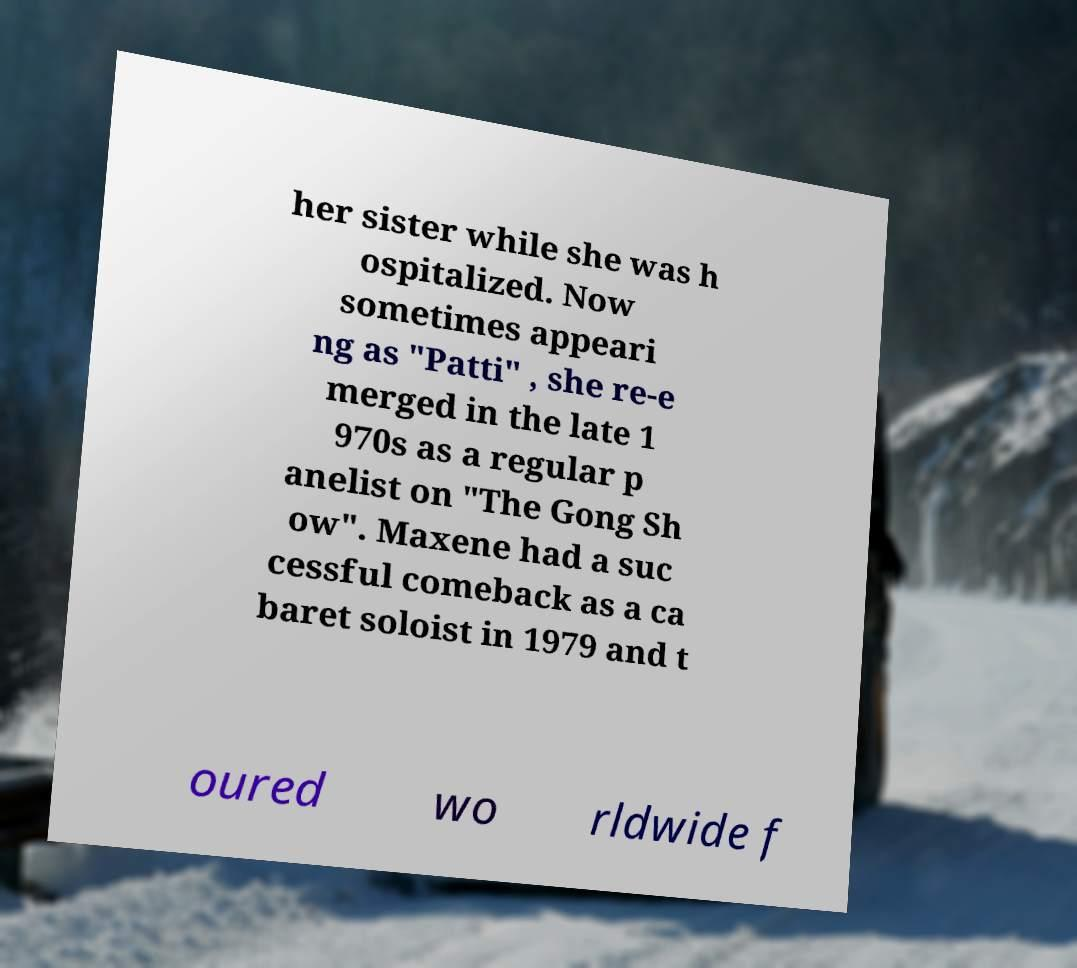I need the written content from this picture converted into text. Can you do that? her sister while she was h ospitalized. Now sometimes appeari ng as "Patti" , she re-e merged in the late 1 970s as a regular p anelist on "The Gong Sh ow". Maxene had a suc cessful comeback as a ca baret soloist in 1979 and t oured wo rldwide f 